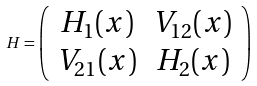Convert formula to latex. <formula><loc_0><loc_0><loc_500><loc_500>H = \left ( \begin{array} { c c } H _ { 1 } ( x ) & V _ { 1 2 } ( x ) \\ V _ { 2 1 } ( x ) & H _ { 2 } ( x ) \end{array} \right )</formula> 